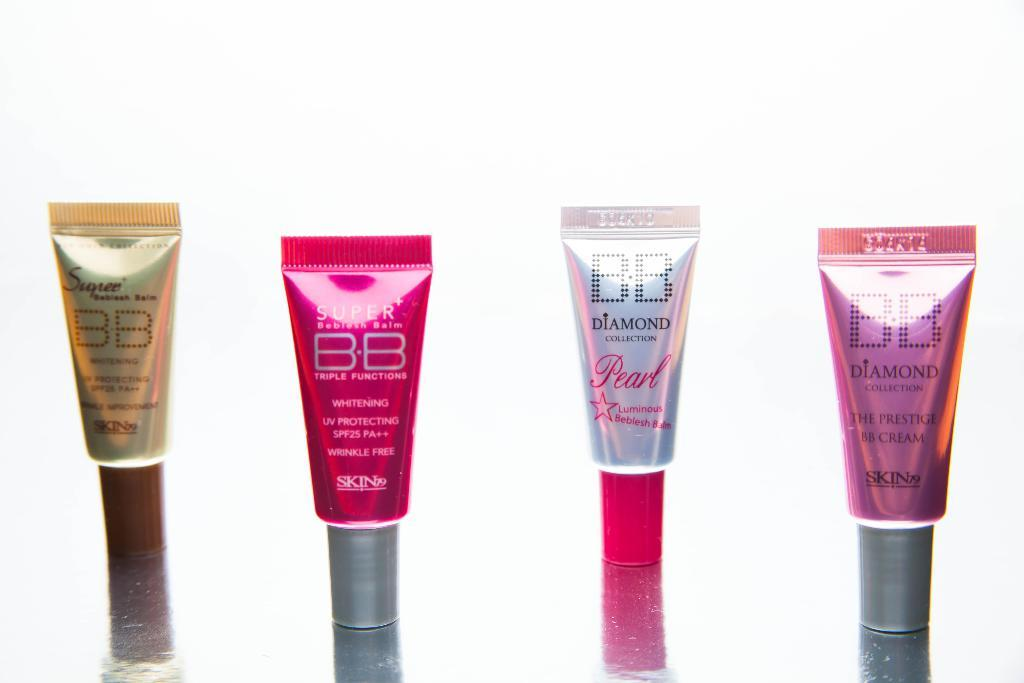How many tubes are visible in the image? There are 4 tubes in the image. Where are the tubes located? The tubes are on a surface. What can be observed about the colors of the tubes? The tubes have different colors. Can you describe the background of the image? The background of the image is blurred. What type of fiction is the maid reading in the image? There is no maid or fiction present in the image; it only features 4 tubes on a surface with a blurred background. 